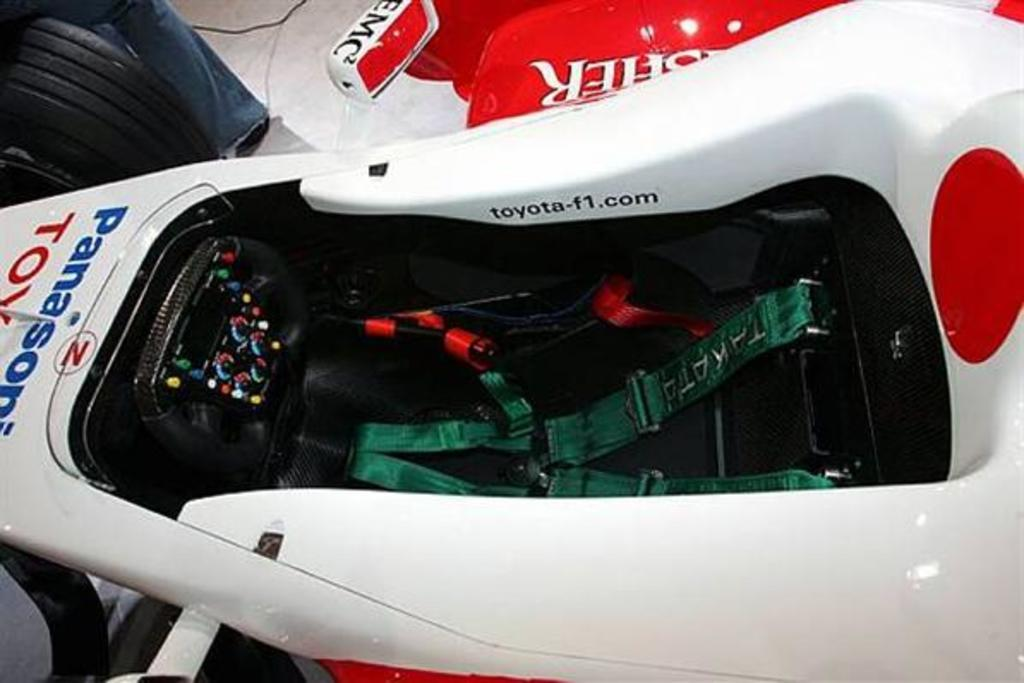What is the main subject in the image? There is a vehicle in the image. What else can be seen in the image besides the vehicle? There is a cable and a person's leg visible on the floor in the image. Can you describe the objects in the image? There are some objects in the image, but their specific details are not mentioned in the provided facts. Can you tell me how many rabbits are drinking juice from the stream in the image? There is no stream, rabbits, or juice present in the image. 